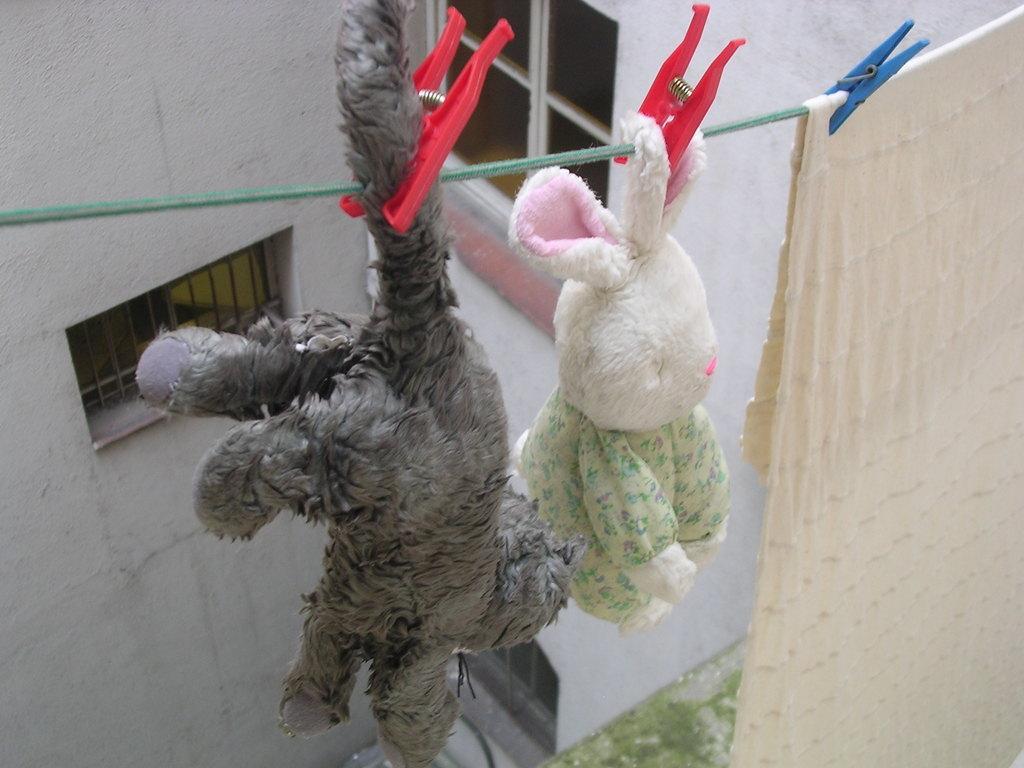In one or two sentences, can you explain what this image depicts? In this image we can see soft toys and a cloth hanging to the rope with the help of clips. In the background there is a building. 